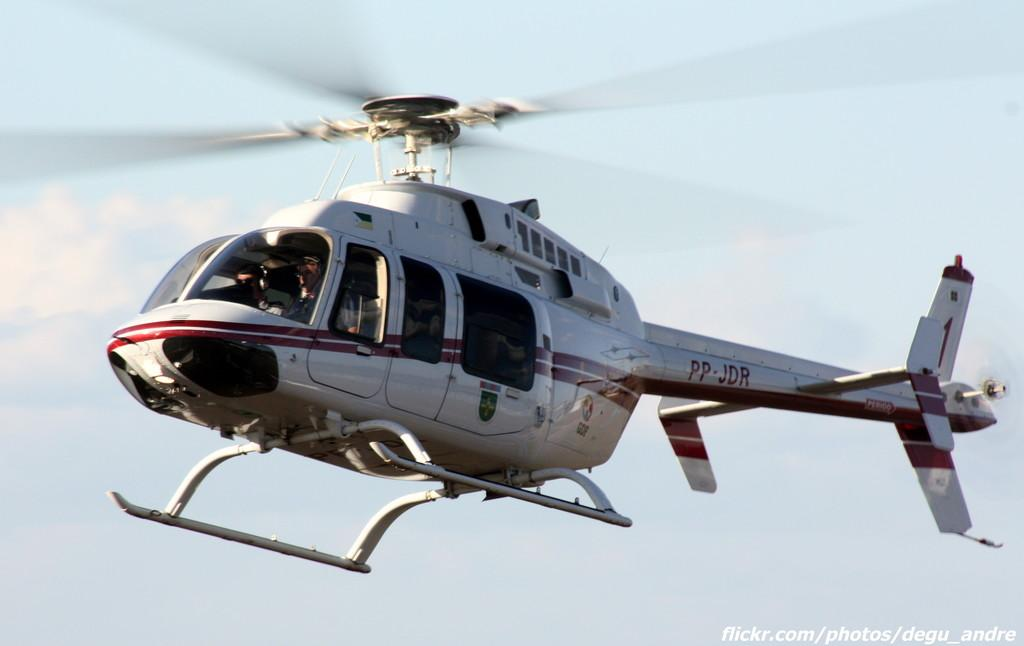<image>
Render a clear and concise summary of the photo. a helicopter in the sky with PP-JDR on the tail 